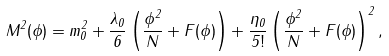<formula> <loc_0><loc_0><loc_500><loc_500>M ^ { 2 } ( \phi ) = m _ { 0 } ^ { 2 } + \frac { \lambda _ { 0 } } { 6 } \left ( \frac { \phi ^ { 2 } } { N } + F ( \phi ) \right ) + \frac { \eta _ { 0 } } { 5 ! } \left ( \frac { \phi ^ { 2 } } { N } + F ( \phi ) \right ) ^ { 2 } ,</formula> 